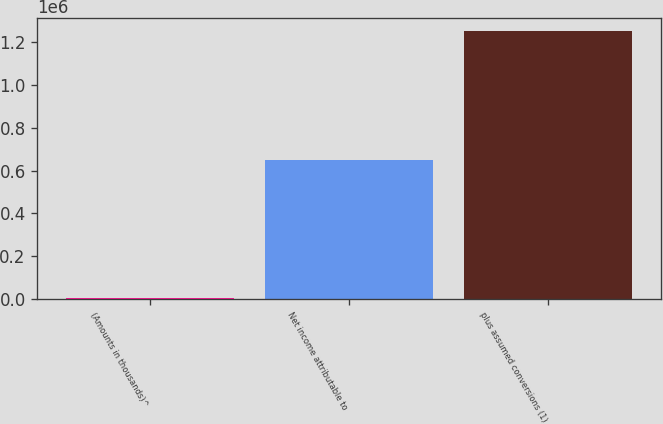<chart> <loc_0><loc_0><loc_500><loc_500><bar_chart><fcel>(Amounts in thousands)^<fcel>Net income attributable to<fcel>plus assumed conversions (1)<nl><fcel>2010<fcel>647883<fcel>1.25153e+06<nl></chart> 